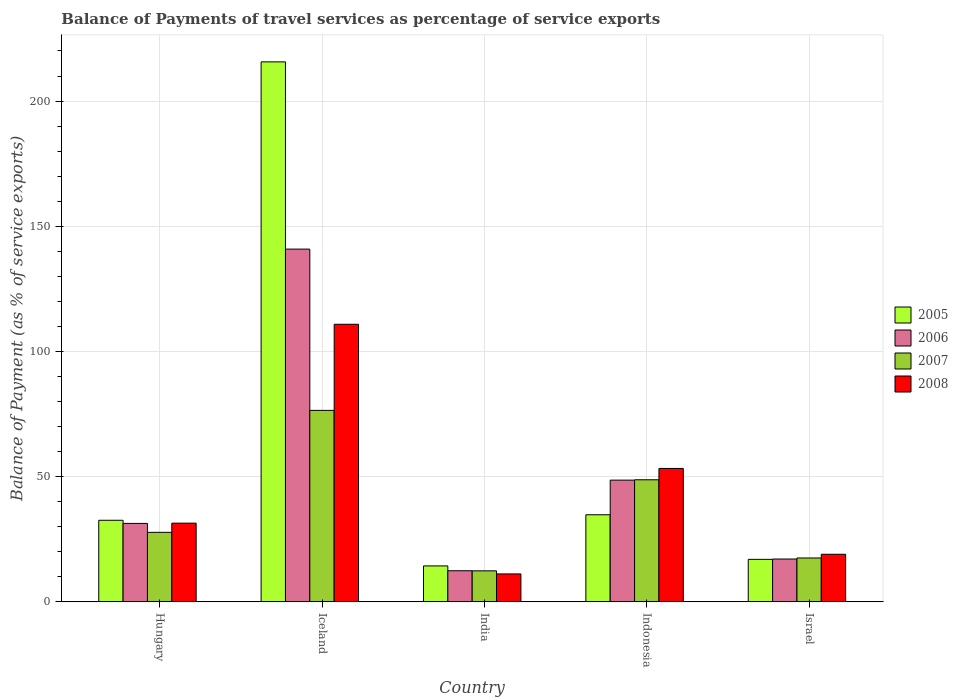How many different coloured bars are there?
Make the answer very short. 4. Are the number of bars per tick equal to the number of legend labels?
Give a very brief answer. Yes. What is the label of the 4th group of bars from the left?
Ensure brevity in your answer.  Indonesia. What is the balance of payments of travel services in 2007 in Israel?
Give a very brief answer. 17.53. Across all countries, what is the maximum balance of payments of travel services in 2007?
Keep it short and to the point. 76.47. Across all countries, what is the minimum balance of payments of travel services in 2008?
Your answer should be very brief. 11.16. In which country was the balance of payments of travel services in 2005 maximum?
Keep it short and to the point. Iceland. What is the total balance of payments of travel services in 2006 in the graph?
Your answer should be compact. 250.37. What is the difference between the balance of payments of travel services in 2006 in Hungary and that in Israel?
Your answer should be compact. 14.22. What is the difference between the balance of payments of travel services in 2005 in Indonesia and the balance of payments of travel services in 2006 in Israel?
Provide a short and direct response. 17.68. What is the average balance of payments of travel services in 2005 per country?
Provide a succinct answer. 62.87. What is the difference between the balance of payments of travel services of/in 2008 and balance of payments of travel services of/in 2007 in Israel?
Offer a very short reply. 1.48. What is the ratio of the balance of payments of travel services in 2008 in Hungary to that in India?
Provide a succinct answer. 2.82. Is the balance of payments of travel services in 2006 in Iceland less than that in India?
Your response must be concise. No. What is the difference between the highest and the second highest balance of payments of travel services in 2007?
Your answer should be very brief. 20.99. What is the difference between the highest and the lowest balance of payments of travel services in 2007?
Provide a short and direct response. 64.07. Is the sum of the balance of payments of travel services in 2005 in Indonesia and Israel greater than the maximum balance of payments of travel services in 2007 across all countries?
Ensure brevity in your answer.  No. What does the 1st bar from the right in Iceland represents?
Your response must be concise. 2008. Is it the case that in every country, the sum of the balance of payments of travel services in 2008 and balance of payments of travel services in 2005 is greater than the balance of payments of travel services in 2006?
Keep it short and to the point. Yes. How many countries are there in the graph?
Keep it short and to the point. 5. Does the graph contain any zero values?
Make the answer very short. No. What is the title of the graph?
Provide a succinct answer. Balance of Payments of travel services as percentage of service exports. Does "2006" appear as one of the legend labels in the graph?
Your answer should be compact. Yes. What is the label or title of the Y-axis?
Give a very brief answer. Balance of Payment (as % of service exports). What is the Balance of Payment (as % of service exports) of 2005 in Hungary?
Your response must be concise. 32.59. What is the Balance of Payment (as % of service exports) in 2006 in Hungary?
Ensure brevity in your answer.  31.33. What is the Balance of Payment (as % of service exports) of 2007 in Hungary?
Your response must be concise. 27.77. What is the Balance of Payment (as % of service exports) of 2008 in Hungary?
Offer a terse response. 31.44. What is the Balance of Payment (as % of service exports) in 2005 in Iceland?
Make the answer very short. 215.64. What is the Balance of Payment (as % of service exports) of 2006 in Iceland?
Your answer should be very brief. 140.88. What is the Balance of Payment (as % of service exports) of 2007 in Iceland?
Ensure brevity in your answer.  76.47. What is the Balance of Payment (as % of service exports) in 2008 in Iceland?
Ensure brevity in your answer.  110.86. What is the Balance of Payment (as % of service exports) in 2005 in India?
Your response must be concise. 14.36. What is the Balance of Payment (as % of service exports) in 2006 in India?
Make the answer very short. 12.43. What is the Balance of Payment (as % of service exports) of 2007 in India?
Offer a terse response. 12.4. What is the Balance of Payment (as % of service exports) in 2008 in India?
Keep it short and to the point. 11.16. What is the Balance of Payment (as % of service exports) in 2005 in Indonesia?
Provide a short and direct response. 34.79. What is the Balance of Payment (as % of service exports) of 2006 in Indonesia?
Make the answer very short. 48.62. What is the Balance of Payment (as % of service exports) of 2007 in Indonesia?
Offer a terse response. 48.76. What is the Balance of Payment (as % of service exports) of 2008 in Indonesia?
Keep it short and to the point. 53.28. What is the Balance of Payment (as % of service exports) in 2005 in Israel?
Ensure brevity in your answer.  16.98. What is the Balance of Payment (as % of service exports) of 2006 in Israel?
Give a very brief answer. 17.11. What is the Balance of Payment (as % of service exports) in 2007 in Israel?
Your answer should be compact. 17.53. What is the Balance of Payment (as % of service exports) in 2008 in Israel?
Offer a terse response. 19.01. Across all countries, what is the maximum Balance of Payment (as % of service exports) of 2005?
Offer a very short reply. 215.64. Across all countries, what is the maximum Balance of Payment (as % of service exports) in 2006?
Provide a short and direct response. 140.88. Across all countries, what is the maximum Balance of Payment (as % of service exports) in 2007?
Offer a very short reply. 76.47. Across all countries, what is the maximum Balance of Payment (as % of service exports) of 2008?
Provide a short and direct response. 110.86. Across all countries, what is the minimum Balance of Payment (as % of service exports) in 2005?
Offer a terse response. 14.36. Across all countries, what is the minimum Balance of Payment (as % of service exports) of 2006?
Offer a terse response. 12.43. Across all countries, what is the minimum Balance of Payment (as % of service exports) in 2007?
Provide a succinct answer. 12.4. Across all countries, what is the minimum Balance of Payment (as % of service exports) in 2008?
Offer a very short reply. 11.16. What is the total Balance of Payment (as % of service exports) of 2005 in the graph?
Make the answer very short. 314.37. What is the total Balance of Payment (as % of service exports) of 2006 in the graph?
Make the answer very short. 250.37. What is the total Balance of Payment (as % of service exports) in 2007 in the graph?
Give a very brief answer. 182.92. What is the total Balance of Payment (as % of service exports) of 2008 in the graph?
Make the answer very short. 225.75. What is the difference between the Balance of Payment (as % of service exports) of 2005 in Hungary and that in Iceland?
Keep it short and to the point. -183.06. What is the difference between the Balance of Payment (as % of service exports) in 2006 in Hungary and that in Iceland?
Your response must be concise. -109.54. What is the difference between the Balance of Payment (as % of service exports) of 2007 in Hungary and that in Iceland?
Ensure brevity in your answer.  -48.7. What is the difference between the Balance of Payment (as % of service exports) in 2008 in Hungary and that in Iceland?
Provide a succinct answer. -79.42. What is the difference between the Balance of Payment (as % of service exports) in 2005 in Hungary and that in India?
Your answer should be very brief. 18.23. What is the difference between the Balance of Payment (as % of service exports) in 2006 in Hungary and that in India?
Give a very brief answer. 18.9. What is the difference between the Balance of Payment (as % of service exports) in 2007 in Hungary and that in India?
Your response must be concise. 15.37. What is the difference between the Balance of Payment (as % of service exports) of 2008 in Hungary and that in India?
Provide a succinct answer. 20.28. What is the difference between the Balance of Payment (as % of service exports) of 2005 in Hungary and that in Indonesia?
Your answer should be very brief. -2.21. What is the difference between the Balance of Payment (as % of service exports) of 2006 in Hungary and that in Indonesia?
Offer a terse response. -17.28. What is the difference between the Balance of Payment (as % of service exports) in 2007 in Hungary and that in Indonesia?
Give a very brief answer. -20.99. What is the difference between the Balance of Payment (as % of service exports) in 2008 in Hungary and that in Indonesia?
Keep it short and to the point. -21.85. What is the difference between the Balance of Payment (as % of service exports) of 2005 in Hungary and that in Israel?
Ensure brevity in your answer.  15.6. What is the difference between the Balance of Payment (as % of service exports) of 2006 in Hungary and that in Israel?
Ensure brevity in your answer.  14.22. What is the difference between the Balance of Payment (as % of service exports) in 2007 in Hungary and that in Israel?
Provide a succinct answer. 10.24. What is the difference between the Balance of Payment (as % of service exports) of 2008 in Hungary and that in Israel?
Your response must be concise. 12.43. What is the difference between the Balance of Payment (as % of service exports) in 2005 in Iceland and that in India?
Offer a very short reply. 201.28. What is the difference between the Balance of Payment (as % of service exports) in 2006 in Iceland and that in India?
Give a very brief answer. 128.44. What is the difference between the Balance of Payment (as % of service exports) in 2007 in Iceland and that in India?
Provide a succinct answer. 64.07. What is the difference between the Balance of Payment (as % of service exports) in 2008 in Iceland and that in India?
Your response must be concise. 99.7. What is the difference between the Balance of Payment (as % of service exports) in 2005 in Iceland and that in Indonesia?
Offer a terse response. 180.85. What is the difference between the Balance of Payment (as % of service exports) of 2006 in Iceland and that in Indonesia?
Make the answer very short. 92.26. What is the difference between the Balance of Payment (as % of service exports) in 2007 in Iceland and that in Indonesia?
Give a very brief answer. 27.71. What is the difference between the Balance of Payment (as % of service exports) of 2008 in Iceland and that in Indonesia?
Give a very brief answer. 57.58. What is the difference between the Balance of Payment (as % of service exports) of 2005 in Iceland and that in Israel?
Keep it short and to the point. 198.66. What is the difference between the Balance of Payment (as % of service exports) in 2006 in Iceland and that in Israel?
Your answer should be very brief. 123.76. What is the difference between the Balance of Payment (as % of service exports) in 2007 in Iceland and that in Israel?
Ensure brevity in your answer.  58.94. What is the difference between the Balance of Payment (as % of service exports) in 2008 in Iceland and that in Israel?
Ensure brevity in your answer.  91.85. What is the difference between the Balance of Payment (as % of service exports) of 2005 in India and that in Indonesia?
Your answer should be compact. -20.43. What is the difference between the Balance of Payment (as % of service exports) of 2006 in India and that in Indonesia?
Provide a succinct answer. -36.18. What is the difference between the Balance of Payment (as % of service exports) of 2007 in India and that in Indonesia?
Your answer should be very brief. -36.36. What is the difference between the Balance of Payment (as % of service exports) of 2008 in India and that in Indonesia?
Ensure brevity in your answer.  -42.13. What is the difference between the Balance of Payment (as % of service exports) of 2005 in India and that in Israel?
Give a very brief answer. -2.62. What is the difference between the Balance of Payment (as % of service exports) in 2006 in India and that in Israel?
Provide a succinct answer. -4.68. What is the difference between the Balance of Payment (as % of service exports) of 2007 in India and that in Israel?
Ensure brevity in your answer.  -5.13. What is the difference between the Balance of Payment (as % of service exports) in 2008 in India and that in Israel?
Your answer should be very brief. -7.85. What is the difference between the Balance of Payment (as % of service exports) of 2005 in Indonesia and that in Israel?
Ensure brevity in your answer.  17.81. What is the difference between the Balance of Payment (as % of service exports) of 2006 in Indonesia and that in Israel?
Offer a very short reply. 31.5. What is the difference between the Balance of Payment (as % of service exports) of 2007 in Indonesia and that in Israel?
Ensure brevity in your answer.  31.23. What is the difference between the Balance of Payment (as % of service exports) of 2008 in Indonesia and that in Israel?
Your response must be concise. 34.27. What is the difference between the Balance of Payment (as % of service exports) in 2005 in Hungary and the Balance of Payment (as % of service exports) in 2006 in Iceland?
Provide a succinct answer. -108.29. What is the difference between the Balance of Payment (as % of service exports) of 2005 in Hungary and the Balance of Payment (as % of service exports) of 2007 in Iceland?
Your response must be concise. -43.88. What is the difference between the Balance of Payment (as % of service exports) of 2005 in Hungary and the Balance of Payment (as % of service exports) of 2008 in Iceland?
Your answer should be compact. -78.27. What is the difference between the Balance of Payment (as % of service exports) of 2006 in Hungary and the Balance of Payment (as % of service exports) of 2007 in Iceland?
Ensure brevity in your answer.  -45.14. What is the difference between the Balance of Payment (as % of service exports) in 2006 in Hungary and the Balance of Payment (as % of service exports) in 2008 in Iceland?
Your answer should be compact. -79.53. What is the difference between the Balance of Payment (as % of service exports) in 2007 in Hungary and the Balance of Payment (as % of service exports) in 2008 in Iceland?
Offer a very short reply. -83.09. What is the difference between the Balance of Payment (as % of service exports) of 2005 in Hungary and the Balance of Payment (as % of service exports) of 2006 in India?
Provide a short and direct response. 20.15. What is the difference between the Balance of Payment (as % of service exports) of 2005 in Hungary and the Balance of Payment (as % of service exports) of 2007 in India?
Your answer should be very brief. 20.19. What is the difference between the Balance of Payment (as % of service exports) of 2005 in Hungary and the Balance of Payment (as % of service exports) of 2008 in India?
Offer a terse response. 21.43. What is the difference between the Balance of Payment (as % of service exports) of 2006 in Hungary and the Balance of Payment (as % of service exports) of 2007 in India?
Your answer should be very brief. 18.94. What is the difference between the Balance of Payment (as % of service exports) in 2006 in Hungary and the Balance of Payment (as % of service exports) in 2008 in India?
Keep it short and to the point. 20.18. What is the difference between the Balance of Payment (as % of service exports) of 2007 in Hungary and the Balance of Payment (as % of service exports) of 2008 in India?
Provide a short and direct response. 16.61. What is the difference between the Balance of Payment (as % of service exports) in 2005 in Hungary and the Balance of Payment (as % of service exports) in 2006 in Indonesia?
Your response must be concise. -16.03. What is the difference between the Balance of Payment (as % of service exports) in 2005 in Hungary and the Balance of Payment (as % of service exports) in 2007 in Indonesia?
Provide a succinct answer. -16.17. What is the difference between the Balance of Payment (as % of service exports) in 2005 in Hungary and the Balance of Payment (as % of service exports) in 2008 in Indonesia?
Provide a short and direct response. -20.7. What is the difference between the Balance of Payment (as % of service exports) in 2006 in Hungary and the Balance of Payment (as % of service exports) in 2007 in Indonesia?
Ensure brevity in your answer.  -17.43. What is the difference between the Balance of Payment (as % of service exports) of 2006 in Hungary and the Balance of Payment (as % of service exports) of 2008 in Indonesia?
Provide a short and direct response. -21.95. What is the difference between the Balance of Payment (as % of service exports) in 2007 in Hungary and the Balance of Payment (as % of service exports) in 2008 in Indonesia?
Your response must be concise. -25.51. What is the difference between the Balance of Payment (as % of service exports) in 2005 in Hungary and the Balance of Payment (as % of service exports) in 2006 in Israel?
Make the answer very short. 15.47. What is the difference between the Balance of Payment (as % of service exports) of 2005 in Hungary and the Balance of Payment (as % of service exports) of 2007 in Israel?
Give a very brief answer. 15.06. What is the difference between the Balance of Payment (as % of service exports) of 2005 in Hungary and the Balance of Payment (as % of service exports) of 2008 in Israel?
Provide a short and direct response. 13.58. What is the difference between the Balance of Payment (as % of service exports) of 2006 in Hungary and the Balance of Payment (as % of service exports) of 2007 in Israel?
Your response must be concise. 13.8. What is the difference between the Balance of Payment (as % of service exports) of 2006 in Hungary and the Balance of Payment (as % of service exports) of 2008 in Israel?
Offer a terse response. 12.32. What is the difference between the Balance of Payment (as % of service exports) in 2007 in Hungary and the Balance of Payment (as % of service exports) in 2008 in Israel?
Give a very brief answer. 8.76. What is the difference between the Balance of Payment (as % of service exports) in 2005 in Iceland and the Balance of Payment (as % of service exports) in 2006 in India?
Keep it short and to the point. 203.21. What is the difference between the Balance of Payment (as % of service exports) in 2005 in Iceland and the Balance of Payment (as % of service exports) in 2007 in India?
Keep it short and to the point. 203.25. What is the difference between the Balance of Payment (as % of service exports) in 2005 in Iceland and the Balance of Payment (as % of service exports) in 2008 in India?
Your answer should be very brief. 204.49. What is the difference between the Balance of Payment (as % of service exports) of 2006 in Iceland and the Balance of Payment (as % of service exports) of 2007 in India?
Provide a short and direct response. 128.48. What is the difference between the Balance of Payment (as % of service exports) of 2006 in Iceland and the Balance of Payment (as % of service exports) of 2008 in India?
Ensure brevity in your answer.  129.72. What is the difference between the Balance of Payment (as % of service exports) of 2007 in Iceland and the Balance of Payment (as % of service exports) of 2008 in India?
Make the answer very short. 65.31. What is the difference between the Balance of Payment (as % of service exports) of 2005 in Iceland and the Balance of Payment (as % of service exports) of 2006 in Indonesia?
Offer a terse response. 167.03. What is the difference between the Balance of Payment (as % of service exports) of 2005 in Iceland and the Balance of Payment (as % of service exports) of 2007 in Indonesia?
Your response must be concise. 166.89. What is the difference between the Balance of Payment (as % of service exports) of 2005 in Iceland and the Balance of Payment (as % of service exports) of 2008 in Indonesia?
Give a very brief answer. 162.36. What is the difference between the Balance of Payment (as % of service exports) in 2006 in Iceland and the Balance of Payment (as % of service exports) in 2007 in Indonesia?
Keep it short and to the point. 92.12. What is the difference between the Balance of Payment (as % of service exports) of 2006 in Iceland and the Balance of Payment (as % of service exports) of 2008 in Indonesia?
Give a very brief answer. 87.59. What is the difference between the Balance of Payment (as % of service exports) in 2007 in Iceland and the Balance of Payment (as % of service exports) in 2008 in Indonesia?
Ensure brevity in your answer.  23.18. What is the difference between the Balance of Payment (as % of service exports) of 2005 in Iceland and the Balance of Payment (as % of service exports) of 2006 in Israel?
Make the answer very short. 198.53. What is the difference between the Balance of Payment (as % of service exports) in 2005 in Iceland and the Balance of Payment (as % of service exports) in 2007 in Israel?
Offer a terse response. 198.12. What is the difference between the Balance of Payment (as % of service exports) in 2005 in Iceland and the Balance of Payment (as % of service exports) in 2008 in Israel?
Your answer should be very brief. 196.64. What is the difference between the Balance of Payment (as % of service exports) of 2006 in Iceland and the Balance of Payment (as % of service exports) of 2007 in Israel?
Your response must be concise. 123.35. What is the difference between the Balance of Payment (as % of service exports) in 2006 in Iceland and the Balance of Payment (as % of service exports) in 2008 in Israel?
Provide a succinct answer. 121.87. What is the difference between the Balance of Payment (as % of service exports) of 2007 in Iceland and the Balance of Payment (as % of service exports) of 2008 in Israel?
Provide a succinct answer. 57.46. What is the difference between the Balance of Payment (as % of service exports) of 2005 in India and the Balance of Payment (as % of service exports) of 2006 in Indonesia?
Make the answer very short. -34.26. What is the difference between the Balance of Payment (as % of service exports) of 2005 in India and the Balance of Payment (as % of service exports) of 2007 in Indonesia?
Provide a short and direct response. -34.4. What is the difference between the Balance of Payment (as % of service exports) of 2005 in India and the Balance of Payment (as % of service exports) of 2008 in Indonesia?
Give a very brief answer. -38.92. What is the difference between the Balance of Payment (as % of service exports) in 2006 in India and the Balance of Payment (as % of service exports) in 2007 in Indonesia?
Ensure brevity in your answer.  -36.33. What is the difference between the Balance of Payment (as % of service exports) in 2006 in India and the Balance of Payment (as % of service exports) in 2008 in Indonesia?
Offer a very short reply. -40.85. What is the difference between the Balance of Payment (as % of service exports) in 2007 in India and the Balance of Payment (as % of service exports) in 2008 in Indonesia?
Ensure brevity in your answer.  -40.89. What is the difference between the Balance of Payment (as % of service exports) in 2005 in India and the Balance of Payment (as % of service exports) in 2006 in Israel?
Your answer should be compact. -2.75. What is the difference between the Balance of Payment (as % of service exports) in 2005 in India and the Balance of Payment (as % of service exports) in 2007 in Israel?
Your answer should be compact. -3.17. What is the difference between the Balance of Payment (as % of service exports) in 2005 in India and the Balance of Payment (as % of service exports) in 2008 in Israel?
Your response must be concise. -4.65. What is the difference between the Balance of Payment (as % of service exports) in 2006 in India and the Balance of Payment (as % of service exports) in 2007 in Israel?
Make the answer very short. -5.09. What is the difference between the Balance of Payment (as % of service exports) of 2006 in India and the Balance of Payment (as % of service exports) of 2008 in Israel?
Provide a succinct answer. -6.58. What is the difference between the Balance of Payment (as % of service exports) of 2007 in India and the Balance of Payment (as % of service exports) of 2008 in Israel?
Your answer should be very brief. -6.61. What is the difference between the Balance of Payment (as % of service exports) in 2005 in Indonesia and the Balance of Payment (as % of service exports) in 2006 in Israel?
Your response must be concise. 17.68. What is the difference between the Balance of Payment (as % of service exports) of 2005 in Indonesia and the Balance of Payment (as % of service exports) of 2007 in Israel?
Make the answer very short. 17.26. What is the difference between the Balance of Payment (as % of service exports) of 2005 in Indonesia and the Balance of Payment (as % of service exports) of 2008 in Israel?
Keep it short and to the point. 15.78. What is the difference between the Balance of Payment (as % of service exports) of 2006 in Indonesia and the Balance of Payment (as % of service exports) of 2007 in Israel?
Your response must be concise. 31.09. What is the difference between the Balance of Payment (as % of service exports) in 2006 in Indonesia and the Balance of Payment (as % of service exports) in 2008 in Israel?
Provide a short and direct response. 29.61. What is the difference between the Balance of Payment (as % of service exports) of 2007 in Indonesia and the Balance of Payment (as % of service exports) of 2008 in Israel?
Your answer should be compact. 29.75. What is the average Balance of Payment (as % of service exports) of 2005 per country?
Your answer should be compact. 62.87. What is the average Balance of Payment (as % of service exports) in 2006 per country?
Your answer should be compact. 50.07. What is the average Balance of Payment (as % of service exports) of 2007 per country?
Ensure brevity in your answer.  36.58. What is the average Balance of Payment (as % of service exports) of 2008 per country?
Give a very brief answer. 45.15. What is the difference between the Balance of Payment (as % of service exports) of 2005 and Balance of Payment (as % of service exports) of 2006 in Hungary?
Provide a short and direct response. 1.25. What is the difference between the Balance of Payment (as % of service exports) of 2005 and Balance of Payment (as % of service exports) of 2007 in Hungary?
Make the answer very short. 4.82. What is the difference between the Balance of Payment (as % of service exports) in 2005 and Balance of Payment (as % of service exports) in 2008 in Hungary?
Your answer should be compact. 1.15. What is the difference between the Balance of Payment (as % of service exports) in 2006 and Balance of Payment (as % of service exports) in 2007 in Hungary?
Give a very brief answer. 3.56. What is the difference between the Balance of Payment (as % of service exports) of 2006 and Balance of Payment (as % of service exports) of 2008 in Hungary?
Offer a very short reply. -0.1. What is the difference between the Balance of Payment (as % of service exports) in 2007 and Balance of Payment (as % of service exports) in 2008 in Hungary?
Provide a short and direct response. -3.67. What is the difference between the Balance of Payment (as % of service exports) in 2005 and Balance of Payment (as % of service exports) in 2006 in Iceland?
Your response must be concise. 74.77. What is the difference between the Balance of Payment (as % of service exports) in 2005 and Balance of Payment (as % of service exports) in 2007 in Iceland?
Keep it short and to the point. 139.18. What is the difference between the Balance of Payment (as % of service exports) of 2005 and Balance of Payment (as % of service exports) of 2008 in Iceland?
Give a very brief answer. 104.78. What is the difference between the Balance of Payment (as % of service exports) of 2006 and Balance of Payment (as % of service exports) of 2007 in Iceland?
Offer a very short reply. 64.41. What is the difference between the Balance of Payment (as % of service exports) of 2006 and Balance of Payment (as % of service exports) of 2008 in Iceland?
Your answer should be very brief. 30.02. What is the difference between the Balance of Payment (as % of service exports) of 2007 and Balance of Payment (as % of service exports) of 2008 in Iceland?
Ensure brevity in your answer.  -34.39. What is the difference between the Balance of Payment (as % of service exports) of 2005 and Balance of Payment (as % of service exports) of 2006 in India?
Make the answer very short. 1.93. What is the difference between the Balance of Payment (as % of service exports) of 2005 and Balance of Payment (as % of service exports) of 2007 in India?
Offer a very short reply. 1.96. What is the difference between the Balance of Payment (as % of service exports) in 2005 and Balance of Payment (as % of service exports) in 2008 in India?
Ensure brevity in your answer.  3.2. What is the difference between the Balance of Payment (as % of service exports) in 2006 and Balance of Payment (as % of service exports) in 2007 in India?
Give a very brief answer. 0.04. What is the difference between the Balance of Payment (as % of service exports) of 2006 and Balance of Payment (as % of service exports) of 2008 in India?
Give a very brief answer. 1.28. What is the difference between the Balance of Payment (as % of service exports) of 2007 and Balance of Payment (as % of service exports) of 2008 in India?
Your answer should be very brief. 1.24. What is the difference between the Balance of Payment (as % of service exports) of 2005 and Balance of Payment (as % of service exports) of 2006 in Indonesia?
Offer a very short reply. -13.83. What is the difference between the Balance of Payment (as % of service exports) in 2005 and Balance of Payment (as % of service exports) in 2007 in Indonesia?
Your response must be concise. -13.97. What is the difference between the Balance of Payment (as % of service exports) of 2005 and Balance of Payment (as % of service exports) of 2008 in Indonesia?
Ensure brevity in your answer.  -18.49. What is the difference between the Balance of Payment (as % of service exports) in 2006 and Balance of Payment (as % of service exports) in 2007 in Indonesia?
Keep it short and to the point. -0.14. What is the difference between the Balance of Payment (as % of service exports) of 2006 and Balance of Payment (as % of service exports) of 2008 in Indonesia?
Provide a short and direct response. -4.67. What is the difference between the Balance of Payment (as % of service exports) of 2007 and Balance of Payment (as % of service exports) of 2008 in Indonesia?
Your answer should be compact. -4.52. What is the difference between the Balance of Payment (as % of service exports) of 2005 and Balance of Payment (as % of service exports) of 2006 in Israel?
Make the answer very short. -0.13. What is the difference between the Balance of Payment (as % of service exports) in 2005 and Balance of Payment (as % of service exports) in 2007 in Israel?
Your answer should be very brief. -0.55. What is the difference between the Balance of Payment (as % of service exports) in 2005 and Balance of Payment (as % of service exports) in 2008 in Israel?
Your answer should be very brief. -2.03. What is the difference between the Balance of Payment (as % of service exports) of 2006 and Balance of Payment (as % of service exports) of 2007 in Israel?
Offer a very short reply. -0.42. What is the difference between the Balance of Payment (as % of service exports) in 2006 and Balance of Payment (as % of service exports) in 2008 in Israel?
Offer a terse response. -1.9. What is the difference between the Balance of Payment (as % of service exports) of 2007 and Balance of Payment (as % of service exports) of 2008 in Israel?
Give a very brief answer. -1.48. What is the ratio of the Balance of Payment (as % of service exports) in 2005 in Hungary to that in Iceland?
Provide a succinct answer. 0.15. What is the ratio of the Balance of Payment (as % of service exports) in 2006 in Hungary to that in Iceland?
Your response must be concise. 0.22. What is the ratio of the Balance of Payment (as % of service exports) in 2007 in Hungary to that in Iceland?
Make the answer very short. 0.36. What is the ratio of the Balance of Payment (as % of service exports) in 2008 in Hungary to that in Iceland?
Provide a succinct answer. 0.28. What is the ratio of the Balance of Payment (as % of service exports) of 2005 in Hungary to that in India?
Ensure brevity in your answer.  2.27. What is the ratio of the Balance of Payment (as % of service exports) in 2006 in Hungary to that in India?
Give a very brief answer. 2.52. What is the ratio of the Balance of Payment (as % of service exports) in 2007 in Hungary to that in India?
Keep it short and to the point. 2.24. What is the ratio of the Balance of Payment (as % of service exports) in 2008 in Hungary to that in India?
Provide a succinct answer. 2.82. What is the ratio of the Balance of Payment (as % of service exports) in 2005 in Hungary to that in Indonesia?
Your answer should be very brief. 0.94. What is the ratio of the Balance of Payment (as % of service exports) of 2006 in Hungary to that in Indonesia?
Offer a terse response. 0.64. What is the ratio of the Balance of Payment (as % of service exports) of 2007 in Hungary to that in Indonesia?
Make the answer very short. 0.57. What is the ratio of the Balance of Payment (as % of service exports) in 2008 in Hungary to that in Indonesia?
Keep it short and to the point. 0.59. What is the ratio of the Balance of Payment (as % of service exports) of 2005 in Hungary to that in Israel?
Ensure brevity in your answer.  1.92. What is the ratio of the Balance of Payment (as % of service exports) in 2006 in Hungary to that in Israel?
Provide a short and direct response. 1.83. What is the ratio of the Balance of Payment (as % of service exports) of 2007 in Hungary to that in Israel?
Ensure brevity in your answer.  1.58. What is the ratio of the Balance of Payment (as % of service exports) in 2008 in Hungary to that in Israel?
Provide a short and direct response. 1.65. What is the ratio of the Balance of Payment (as % of service exports) of 2005 in Iceland to that in India?
Offer a very short reply. 15.02. What is the ratio of the Balance of Payment (as % of service exports) in 2006 in Iceland to that in India?
Offer a very short reply. 11.33. What is the ratio of the Balance of Payment (as % of service exports) of 2007 in Iceland to that in India?
Make the answer very short. 6.17. What is the ratio of the Balance of Payment (as % of service exports) of 2008 in Iceland to that in India?
Offer a terse response. 9.94. What is the ratio of the Balance of Payment (as % of service exports) of 2005 in Iceland to that in Indonesia?
Give a very brief answer. 6.2. What is the ratio of the Balance of Payment (as % of service exports) of 2006 in Iceland to that in Indonesia?
Keep it short and to the point. 2.9. What is the ratio of the Balance of Payment (as % of service exports) of 2007 in Iceland to that in Indonesia?
Your answer should be very brief. 1.57. What is the ratio of the Balance of Payment (as % of service exports) of 2008 in Iceland to that in Indonesia?
Offer a very short reply. 2.08. What is the ratio of the Balance of Payment (as % of service exports) of 2005 in Iceland to that in Israel?
Provide a succinct answer. 12.7. What is the ratio of the Balance of Payment (as % of service exports) in 2006 in Iceland to that in Israel?
Offer a very short reply. 8.23. What is the ratio of the Balance of Payment (as % of service exports) in 2007 in Iceland to that in Israel?
Give a very brief answer. 4.36. What is the ratio of the Balance of Payment (as % of service exports) of 2008 in Iceland to that in Israel?
Your answer should be compact. 5.83. What is the ratio of the Balance of Payment (as % of service exports) in 2005 in India to that in Indonesia?
Ensure brevity in your answer.  0.41. What is the ratio of the Balance of Payment (as % of service exports) of 2006 in India to that in Indonesia?
Your answer should be very brief. 0.26. What is the ratio of the Balance of Payment (as % of service exports) in 2007 in India to that in Indonesia?
Offer a very short reply. 0.25. What is the ratio of the Balance of Payment (as % of service exports) in 2008 in India to that in Indonesia?
Your answer should be compact. 0.21. What is the ratio of the Balance of Payment (as % of service exports) in 2005 in India to that in Israel?
Your answer should be compact. 0.85. What is the ratio of the Balance of Payment (as % of service exports) in 2006 in India to that in Israel?
Give a very brief answer. 0.73. What is the ratio of the Balance of Payment (as % of service exports) in 2007 in India to that in Israel?
Keep it short and to the point. 0.71. What is the ratio of the Balance of Payment (as % of service exports) of 2008 in India to that in Israel?
Your response must be concise. 0.59. What is the ratio of the Balance of Payment (as % of service exports) of 2005 in Indonesia to that in Israel?
Provide a succinct answer. 2.05. What is the ratio of the Balance of Payment (as % of service exports) of 2006 in Indonesia to that in Israel?
Offer a terse response. 2.84. What is the ratio of the Balance of Payment (as % of service exports) in 2007 in Indonesia to that in Israel?
Provide a succinct answer. 2.78. What is the ratio of the Balance of Payment (as % of service exports) of 2008 in Indonesia to that in Israel?
Offer a very short reply. 2.8. What is the difference between the highest and the second highest Balance of Payment (as % of service exports) of 2005?
Offer a very short reply. 180.85. What is the difference between the highest and the second highest Balance of Payment (as % of service exports) of 2006?
Your answer should be compact. 92.26. What is the difference between the highest and the second highest Balance of Payment (as % of service exports) in 2007?
Your answer should be compact. 27.71. What is the difference between the highest and the second highest Balance of Payment (as % of service exports) of 2008?
Offer a very short reply. 57.58. What is the difference between the highest and the lowest Balance of Payment (as % of service exports) in 2005?
Your answer should be very brief. 201.28. What is the difference between the highest and the lowest Balance of Payment (as % of service exports) in 2006?
Make the answer very short. 128.44. What is the difference between the highest and the lowest Balance of Payment (as % of service exports) in 2007?
Your answer should be very brief. 64.07. What is the difference between the highest and the lowest Balance of Payment (as % of service exports) of 2008?
Give a very brief answer. 99.7. 